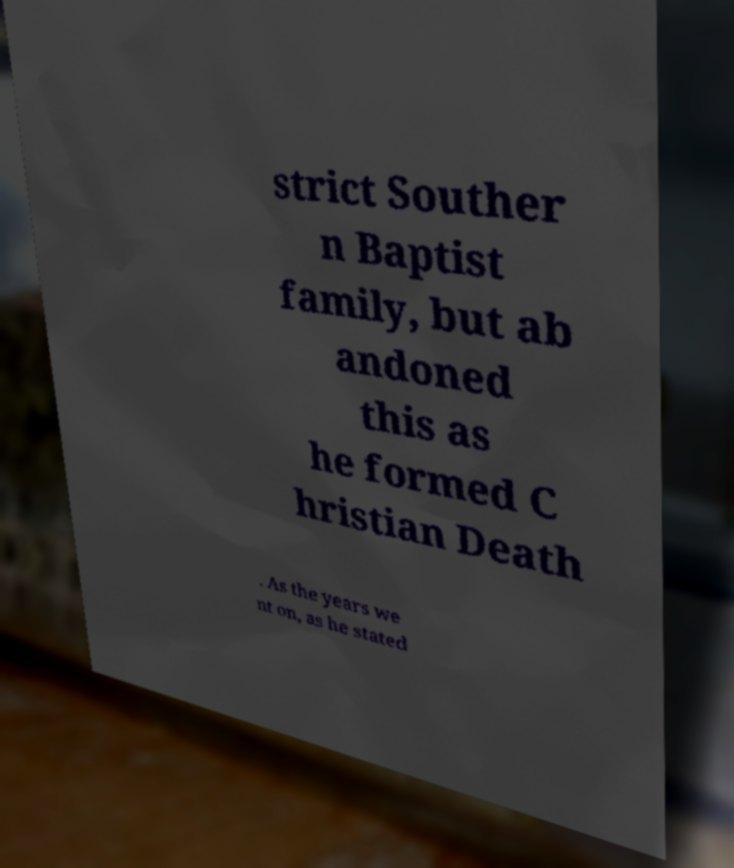Could you extract and type out the text from this image? strict Souther n Baptist family, but ab andoned this as he formed C hristian Death . As the years we nt on, as he stated 